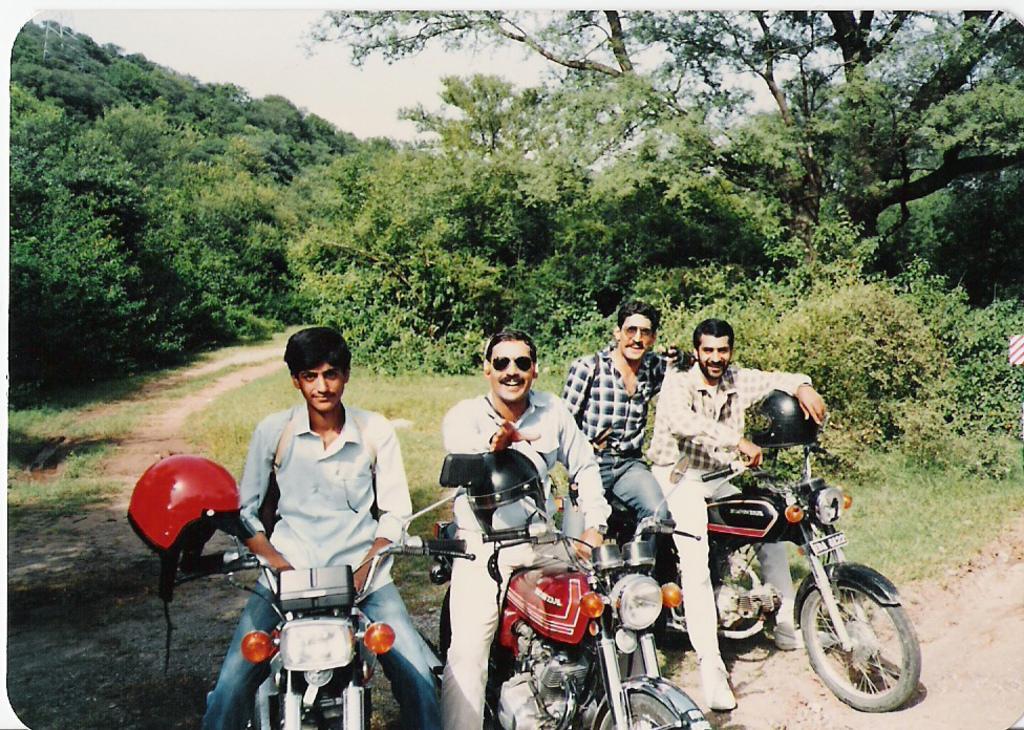Describe this image in one or two sentences. This picture is outside of the city, it is very sunny. There are four persons sitting on their bikes and having smile on their faces. In the background there are some trees, sky and the grass on the floor on the bike which is on left side there is one red colour helmet in the center black colour helmet is attached to this bike and the right side this man is leaning on the black colour helmet. 